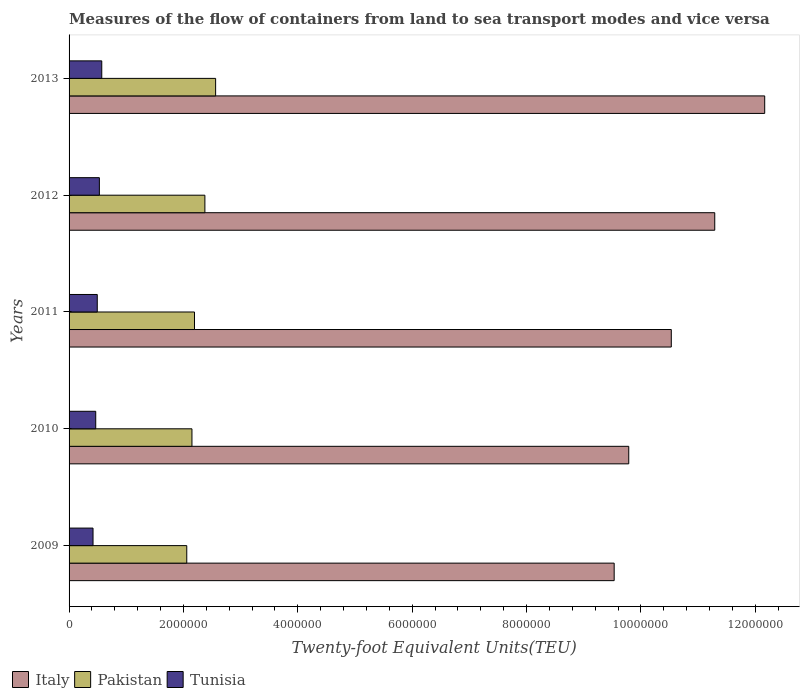How many bars are there on the 4th tick from the top?
Provide a succinct answer. 3. How many bars are there on the 4th tick from the bottom?
Keep it short and to the point. 3. In how many cases, is the number of bars for a given year not equal to the number of legend labels?
Keep it short and to the point. 0. What is the container port traffic in Pakistan in 2009?
Make the answer very short. 2.06e+06. Across all years, what is the maximum container port traffic in Pakistan?
Give a very brief answer. 2.56e+06. Across all years, what is the minimum container port traffic in Tunisia?
Provide a succinct answer. 4.19e+05. What is the total container port traffic in Pakistan in the graph?
Provide a short and direct response. 1.13e+07. What is the difference between the container port traffic in Italy in 2010 and that in 2011?
Ensure brevity in your answer.  -7.44e+05. What is the difference between the container port traffic in Italy in 2010 and the container port traffic in Pakistan in 2009?
Keep it short and to the point. 7.73e+06. What is the average container port traffic in Tunisia per year?
Provide a short and direct response. 4.96e+05. In the year 2012, what is the difference between the container port traffic in Tunisia and container port traffic in Pakistan?
Offer a terse response. -1.85e+06. In how many years, is the container port traffic in Tunisia greater than 4800000 TEU?
Offer a terse response. 0. What is the ratio of the container port traffic in Pakistan in 2012 to that in 2013?
Your response must be concise. 0.93. What is the difference between the highest and the second highest container port traffic in Tunisia?
Your answer should be compact. 4.19e+04. What is the difference between the highest and the lowest container port traffic in Pakistan?
Offer a terse response. 5.05e+05. Is the sum of the container port traffic in Tunisia in 2009 and 2012 greater than the maximum container port traffic in Italy across all years?
Ensure brevity in your answer.  No. What does the 2nd bar from the top in 2009 represents?
Offer a very short reply. Pakistan. How many bars are there?
Ensure brevity in your answer.  15. What is the difference between two consecutive major ticks on the X-axis?
Your response must be concise. 2.00e+06. How many legend labels are there?
Keep it short and to the point. 3. What is the title of the graph?
Your answer should be very brief. Measures of the flow of containers from land to sea transport modes and vice versa. What is the label or title of the X-axis?
Offer a very short reply. Twenty-foot Equivalent Units(TEU). What is the Twenty-foot Equivalent Units(TEU) in Italy in 2009?
Offer a very short reply. 9.53e+06. What is the Twenty-foot Equivalent Units(TEU) of Pakistan in 2009?
Your answer should be very brief. 2.06e+06. What is the Twenty-foot Equivalent Units(TEU) in Tunisia in 2009?
Offer a terse response. 4.19e+05. What is the Twenty-foot Equivalent Units(TEU) in Italy in 2010?
Provide a short and direct response. 9.79e+06. What is the Twenty-foot Equivalent Units(TEU) in Pakistan in 2010?
Your answer should be compact. 2.15e+06. What is the Twenty-foot Equivalent Units(TEU) of Tunisia in 2010?
Keep it short and to the point. 4.66e+05. What is the Twenty-foot Equivalent Units(TEU) of Italy in 2011?
Your answer should be compact. 1.05e+07. What is the Twenty-foot Equivalent Units(TEU) of Pakistan in 2011?
Provide a succinct answer. 2.19e+06. What is the Twenty-foot Equivalent Units(TEU) of Tunisia in 2011?
Your response must be concise. 4.93e+05. What is the Twenty-foot Equivalent Units(TEU) of Italy in 2012?
Make the answer very short. 1.13e+07. What is the Twenty-foot Equivalent Units(TEU) of Pakistan in 2012?
Give a very brief answer. 2.38e+06. What is the Twenty-foot Equivalent Units(TEU) of Tunisia in 2012?
Your answer should be compact. 5.30e+05. What is the Twenty-foot Equivalent Units(TEU) in Italy in 2013?
Provide a short and direct response. 1.22e+07. What is the Twenty-foot Equivalent Units(TEU) in Pakistan in 2013?
Offer a very short reply. 2.56e+06. What is the Twenty-foot Equivalent Units(TEU) in Tunisia in 2013?
Offer a terse response. 5.72e+05. Across all years, what is the maximum Twenty-foot Equivalent Units(TEU) of Italy?
Give a very brief answer. 1.22e+07. Across all years, what is the maximum Twenty-foot Equivalent Units(TEU) in Pakistan?
Keep it short and to the point. 2.56e+06. Across all years, what is the maximum Twenty-foot Equivalent Units(TEU) in Tunisia?
Provide a short and direct response. 5.72e+05. Across all years, what is the minimum Twenty-foot Equivalent Units(TEU) of Italy?
Provide a succinct answer. 9.53e+06. Across all years, what is the minimum Twenty-foot Equivalent Units(TEU) in Pakistan?
Offer a terse response. 2.06e+06. Across all years, what is the minimum Twenty-foot Equivalent Units(TEU) of Tunisia?
Give a very brief answer. 4.19e+05. What is the total Twenty-foot Equivalent Units(TEU) in Italy in the graph?
Ensure brevity in your answer.  5.33e+07. What is the total Twenty-foot Equivalent Units(TEU) of Pakistan in the graph?
Your answer should be very brief. 1.13e+07. What is the total Twenty-foot Equivalent Units(TEU) in Tunisia in the graph?
Your response must be concise. 2.48e+06. What is the difference between the Twenty-foot Equivalent Units(TEU) in Italy in 2009 and that in 2010?
Your answer should be compact. -2.55e+05. What is the difference between the Twenty-foot Equivalent Units(TEU) in Pakistan in 2009 and that in 2010?
Your response must be concise. -9.09e+04. What is the difference between the Twenty-foot Equivalent Units(TEU) in Tunisia in 2009 and that in 2010?
Your answer should be compact. -4.75e+04. What is the difference between the Twenty-foot Equivalent Units(TEU) of Italy in 2009 and that in 2011?
Keep it short and to the point. -9.99e+05. What is the difference between the Twenty-foot Equivalent Units(TEU) in Pakistan in 2009 and that in 2011?
Provide a succinct answer. -1.35e+05. What is the difference between the Twenty-foot Equivalent Units(TEU) in Tunisia in 2009 and that in 2011?
Your answer should be very brief. -7.41e+04. What is the difference between the Twenty-foot Equivalent Units(TEU) of Italy in 2009 and that in 2012?
Keep it short and to the point. -1.76e+06. What is the difference between the Twenty-foot Equivalent Units(TEU) of Pakistan in 2009 and that in 2012?
Your response must be concise. -3.17e+05. What is the difference between the Twenty-foot Equivalent Units(TEU) in Tunisia in 2009 and that in 2012?
Ensure brevity in your answer.  -1.11e+05. What is the difference between the Twenty-foot Equivalent Units(TEU) in Italy in 2009 and that in 2013?
Ensure brevity in your answer.  -2.63e+06. What is the difference between the Twenty-foot Equivalent Units(TEU) of Pakistan in 2009 and that in 2013?
Your answer should be very brief. -5.05e+05. What is the difference between the Twenty-foot Equivalent Units(TEU) of Tunisia in 2009 and that in 2013?
Ensure brevity in your answer.  -1.53e+05. What is the difference between the Twenty-foot Equivalent Units(TEU) of Italy in 2010 and that in 2011?
Provide a succinct answer. -7.44e+05. What is the difference between the Twenty-foot Equivalent Units(TEU) of Pakistan in 2010 and that in 2011?
Keep it short and to the point. -4.44e+04. What is the difference between the Twenty-foot Equivalent Units(TEU) in Tunisia in 2010 and that in 2011?
Your answer should be compact. -2.66e+04. What is the difference between the Twenty-foot Equivalent Units(TEU) of Italy in 2010 and that in 2012?
Make the answer very short. -1.50e+06. What is the difference between the Twenty-foot Equivalent Units(TEU) in Pakistan in 2010 and that in 2012?
Provide a short and direct response. -2.26e+05. What is the difference between the Twenty-foot Equivalent Units(TEU) of Tunisia in 2010 and that in 2012?
Ensure brevity in your answer.  -6.36e+04. What is the difference between the Twenty-foot Equivalent Units(TEU) in Italy in 2010 and that in 2013?
Your answer should be very brief. -2.38e+06. What is the difference between the Twenty-foot Equivalent Units(TEU) in Pakistan in 2010 and that in 2013?
Offer a very short reply. -4.14e+05. What is the difference between the Twenty-foot Equivalent Units(TEU) in Tunisia in 2010 and that in 2013?
Provide a short and direct response. -1.05e+05. What is the difference between the Twenty-foot Equivalent Units(TEU) of Italy in 2011 and that in 2012?
Provide a short and direct response. -7.60e+05. What is the difference between the Twenty-foot Equivalent Units(TEU) of Pakistan in 2011 and that in 2012?
Keep it short and to the point. -1.82e+05. What is the difference between the Twenty-foot Equivalent Units(TEU) of Tunisia in 2011 and that in 2012?
Provide a short and direct response. -3.70e+04. What is the difference between the Twenty-foot Equivalent Units(TEU) in Italy in 2011 and that in 2013?
Provide a short and direct response. -1.63e+06. What is the difference between the Twenty-foot Equivalent Units(TEU) in Pakistan in 2011 and that in 2013?
Give a very brief answer. -3.69e+05. What is the difference between the Twenty-foot Equivalent Units(TEU) in Tunisia in 2011 and that in 2013?
Offer a terse response. -7.88e+04. What is the difference between the Twenty-foot Equivalent Units(TEU) of Italy in 2012 and that in 2013?
Your answer should be compact. -8.74e+05. What is the difference between the Twenty-foot Equivalent Units(TEU) in Pakistan in 2012 and that in 2013?
Your answer should be very brief. -1.88e+05. What is the difference between the Twenty-foot Equivalent Units(TEU) in Tunisia in 2012 and that in 2013?
Make the answer very short. -4.19e+04. What is the difference between the Twenty-foot Equivalent Units(TEU) in Italy in 2009 and the Twenty-foot Equivalent Units(TEU) in Pakistan in 2010?
Keep it short and to the point. 7.38e+06. What is the difference between the Twenty-foot Equivalent Units(TEU) in Italy in 2009 and the Twenty-foot Equivalent Units(TEU) in Tunisia in 2010?
Offer a terse response. 9.07e+06. What is the difference between the Twenty-foot Equivalent Units(TEU) in Pakistan in 2009 and the Twenty-foot Equivalent Units(TEU) in Tunisia in 2010?
Your answer should be very brief. 1.59e+06. What is the difference between the Twenty-foot Equivalent Units(TEU) in Italy in 2009 and the Twenty-foot Equivalent Units(TEU) in Pakistan in 2011?
Give a very brief answer. 7.34e+06. What is the difference between the Twenty-foot Equivalent Units(TEU) of Italy in 2009 and the Twenty-foot Equivalent Units(TEU) of Tunisia in 2011?
Provide a short and direct response. 9.04e+06. What is the difference between the Twenty-foot Equivalent Units(TEU) of Pakistan in 2009 and the Twenty-foot Equivalent Units(TEU) of Tunisia in 2011?
Your answer should be very brief. 1.57e+06. What is the difference between the Twenty-foot Equivalent Units(TEU) in Italy in 2009 and the Twenty-foot Equivalent Units(TEU) in Pakistan in 2012?
Your response must be concise. 7.16e+06. What is the difference between the Twenty-foot Equivalent Units(TEU) of Italy in 2009 and the Twenty-foot Equivalent Units(TEU) of Tunisia in 2012?
Keep it short and to the point. 9.00e+06. What is the difference between the Twenty-foot Equivalent Units(TEU) of Pakistan in 2009 and the Twenty-foot Equivalent Units(TEU) of Tunisia in 2012?
Ensure brevity in your answer.  1.53e+06. What is the difference between the Twenty-foot Equivalent Units(TEU) in Italy in 2009 and the Twenty-foot Equivalent Units(TEU) in Pakistan in 2013?
Your response must be concise. 6.97e+06. What is the difference between the Twenty-foot Equivalent Units(TEU) of Italy in 2009 and the Twenty-foot Equivalent Units(TEU) of Tunisia in 2013?
Give a very brief answer. 8.96e+06. What is the difference between the Twenty-foot Equivalent Units(TEU) of Pakistan in 2009 and the Twenty-foot Equivalent Units(TEU) of Tunisia in 2013?
Offer a very short reply. 1.49e+06. What is the difference between the Twenty-foot Equivalent Units(TEU) in Italy in 2010 and the Twenty-foot Equivalent Units(TEU) in Pakistan in 2011?
Keep it short and to the point. 7.59e+06. What is the difference between the Twenty-foot Equivalent Units(TEU) in Italy in 2010 and the Twenty-foot Equivalent Units(TEU) in Tunisia in 2011?
Give a very brief answer. 9.29e+06. What is the difference between the Twenty-foot Equivalent Units(TEU) of Pakistan in 2010 and the Twenty-foot Equivalent Units(TEU) of Tunisia in 2011?
Offer a very short reply. 1.66e+06. What is the difference between the Twenty-foot Equivalent Units(TEU) in Italy in 2010 and the Twenty-foot Equivalent Units(TEU) in Pakistan in 2012?
Offer a terse response. 7.41e+06. What is the difference between the Twenty-foot Equivalent Units(TEU) of Italy in 2010 and the Twenty-foot Equivalent Units(TEU) of Tunisia in 2012?
Give a very brief answer. 9.26e+06. What is the difference between the Twenty-foot Equivalent Units(TEU) in Pakistan in 2010 and the Twenty-foot Equivalent Units(TEU) in Tunisia in 2012?
Make the answer very short. 1.62e+06. What is the difference between the Twenty-foot Equivalent Units(TEU) in Italy in 2010 and the Twenty-foot Equivalent Units(TEU) in Pakistan in 2013?
Provide a short and direct response. 7.22e+06. What is the difference between the Twenty-foot Equivalent Units(TEU) of Italy in 2010 and the Twenty-foot Equivalent Units(TEU) of Tunisia in 2013?
Your answer should be compact. 9.22e+06. What is the difference between the Twenty-foot Equivalent Units(TEU) of Pakistan in 2010 and the Twenty-foot Equivalent Units(TEU) of Tunisia in 2013?
Your answer should be compact. 1.58e+06. What is the difference between the Twenty-foot Equivalent Units(TEU) of Italy in 2011 and the Twenty-foot Equivalent Units(TEU) of Pakistan in 2012?
Provide a short and direct response. 8.16e+06. What is the difference between the Twenty-foot Equivalent Units(TEU) of Italy in 2011 and the Twenty-foot Equivalent Units(TEU) of Tunisia in 2012?
Your answer should be compact. 1.00e+07. What is the difference between the Twenty-foot Equivalent Units(TEU) in Pakistan in 2011 and the Twenty-foot Equivalent Units(TEU) in Tunisia in 2012?
Provide a short and direct response. 1.66e+06. What is the difference between the Twenty-foot Equivalent Units(TEU) of Italy in 2011 and the Twenty-foot Equivalent Units(TEU) of Pakistan in 2013?
Offer a very short reply. 7.97e+06. What is the difference between the Twenty-foot Equivalent Units(TEU) in Italy in 2011 and the Twenty-foot Equivalent Units(TEU) in Tunisia in 2013?
Give a very brief answer. 9.96e+06. What is the difference between the Twenty-foot Equivalent Units(TEU) of Pakistan in 2011 and the Twenty-foot Equivalent Units(TEU) of Tunisia in 2013?
Your answer should be very brief. 1.62e+06. What is the difference between the Twenty-foot Equivalent Units(TEU) of Italy in 2012 and the Twenty-foot Equivalent Units(TEU) of Pakistan in 2013?
Offer a terse response. 8.73e+06. What is the difference between the Twenty-foot Equivalent Units(TEU) of Italy in 2012 and the Twenty-foot Equivalent Units(TEU) of Tunisia in 2013?
Ensure brevity in your answer.  1.07e+07. What is the difference between the Twenty-foot Equivalent Units(TEU) of Pakistan in 2012 and the Twenty-foot Equivalent Units(TEU) of Tunisia in 2013?
Provide a succinct answer. 1.80e+06. What is the average Twenty-foot Equivalent Units(TEU) of Italy per year?
Provide a short and direct response. 1.07e+07. What is the average Twenty-foot Equivalent Units(TEU) of Pakistan per year?
Keep it short and to the point. 2.27e+06. What is the average Twenty-foot Equivalent Units(TEU) in Tunisia per year?
Keep it short and to the point. 4.96e+05. In the year 2009, what is the difference between the Twenty-foot Equivalent Units(TEU) in Italy and Twenty-foot Equivalent Units(TEU) in Pakistan?
Your answer should be very brief. 7.47e+06. In the year 2009, what is the difference between the Twenty-foot Equivalent Units(TEU) of Italy and Twenty-foot Equivalent Units(TEU) of Tunisia?
Offer a terse response. 9.11e+06. In the year 2009, what is the difference between the Twenty-foot Equivalent Units(TEU) in Pakistan and Twenty-foot Equivalent Units(TEU) in Tunisia?
Provide a short and direct response. 1.64e+06. In the year 2010, what is the difference between the Twenty-foot Equivalent Units(TEU) in Italy and Twenty-foot Equivalent Units(TEU) in Pakistan?
Provide a short and direct response. 7.64e+06. In the year 2010, what is the difference between the Twenty-foot Equivalent Units(TEU) in Italy and Twenty-foot Equivalent Units(TEU) in Tunisia?
Your answer should be very brief. 9.32e+06. In the year 2010, what is the difference between the Twenty-foot Equivalent Units(TEU) of Pakistan and Twenty-foot Equivalent Units(TEU) of Tunisia?
Keep it short and to the point. 1.68e+06. In the year 2011, what is the difference between the Twenty-foot Equivalent Units(TEU) of Italy and Twenty-foot Equivalent Units(TEU) of Pakistan?
Give a very brief answer. 8.34e+06. In the year 2011, what is the difference between the Twenty-foot Equivalent Units(TEU) of Italy and Twenty-foot Equivalent Units(TEU) of Tunisia?
Your answer should be very brief. 1.00e+07. In the year 2011, what is the difference between the Twenty-foot Equivalent Units(TEU) of Pakistan and Twenty-foot Equivalent Units(TEU) of Tunisia?
Ensure brevity in your answer.  1.70e+06. In the year 2012, what is the difference between the Twenty-foot Equivalent Units(TEU) in Italy and Twenty-foot Equivalent Units(TEU) in Pakistan?
Ensure brevity in your answer.  8.92e+06. In the year 2012, what is the difference between the Twenty-foot Equivalent Units(TEU) of Italy and Twenty-foot Equivalent Units(TEU) of Tunisia?
Your response must be concise. 1.08e+07. In the year 2012, what is the difference between the Twenty-foot Equivalent Units(TEU) of Pakistan and Twenty-foot Equivalent Units(TEU) of Tunisia?
Your answer should be compact. 1.85e+06. In the year 2013, what is the difference between the Twenty-foot Equivalent Units(TEU) in Italy and Twenty-foot Equivalent Units(TEU) in Pakistan?
Your response must be concise. 9.60e+06. In the year 2013, what is the difference between the Twenty-foot Equivalent Units(TEU) in Italy and Twenty-foot Equivalent Units(TEU) in Tunisia?
Provide a short and direct response. 1.16e+07. In the year 2013, what is the difference between the Twenty-foot Equivalent Units(TEU) of Pakistan and Twenty-foot Equivalent Units(TEU) of Tunisia?
Keep it short and to the point. 1.99e+06. What is the ratio of the Twenty-foot Equivalent Units(TEU) in Italy in 2009 to that in 2010?
Your response must be concise. 0.97. What is the ratio of the Twenty-foot Equivalent Units(TEU) in Pakistan in 2009 to that in 2010?
Make the answer very short. 0.96. What is the ratio of the Twenty-foot Equivalent Units(TEU) of Tunisia in 2009 to that in 2010?
Your answer should be compact. 0.9. What is the ratio of the Twenty-foot Equivalent Units(TEU) of Italy in 2009 to that in 2011?
Offer a very short reply. 0.91. What is the ratio of the Twenty-foot Equivalent Units(TEU) of Pakistan in 2009 to that in 2011?
Offer a very short reply. 0.94. What is the ratio of the Twenty-foot Equivalent Units(TEU) of Tunisia in 2009 to that in 2011?
Your answer should be compact. 0.85. What is the ratio of the Twenty-foot Equivalent Units(TEU) in Italy in 2009 to that in 2012?
Your answer should be compact. 0.84. What is the ratio of the Twenty-foot Equivalent Units(TEU) in Pakistan in 2009 to that in 2012?
Provide a succinct answer. 0.87. What is the ratio of the Twenty-foot Equivalent Units(TEU) of Tunisia in 2009 to that in 2012?
Offer a terse response. 0.79. What is the ratio of the Twenty-foot Equivalent Units(TEU) in Italy in 2009 to that in 2013?
Provide a short and direct response. 0.78. What is the ratio of the Twenty-foot Equivalent Units(TEU) in Pakistan in 2009 to that in 2013?
Provide a short and direct response. 0.8. What is the ratio of the Twenty-foot Equivalent Units(TEU) in Tunisia in 2009 to that in 2013?
Keep it short and to the point. 0.73. What is the ratio of the Twenty-foot Equivalent Units(TEU) of Italy in 2010 to that in 2011?
Your answer should be compact. 0.93. What is the ratio of the Twenty-foot Equivalent Units(TEU) of Pakistan in 2010 to that in 2011?
Give a very brief answer. 0.98. What is the ratio of the Twenty-foot Equivalent Units(TEU) in Tunisia in 2010 to that in 2011?
Keep it short and to the point. 0.95. What is the ratio of the Twenty-foot Equivalent Units(TEU) of Italy in 2010 to that in 2012?
Your answer should be very brief. 0.87. What is the ratio of the Twenty-foot Equivalent Units(TEU) in Pakistan in 2010 to that in 2012?
Provide a succinct answer. 0.9. What is the ratio of the Twenty-foot Equivalent Units(TEU) in Tunisia in 2010 to that in 2012?
Provide a short and direct response. 0.88. What is the ratio of the Twenty-foot Equivalent Units(TEU) in Italy in 2010 to that in 2013?
Make the answer very short. 0.8. What is the ratio of the Twenty-foot Equivalent Units(TEU) in Pakistan in 2010 to that in 2013?
Provide a succinct answer. 0.84. What is the ratio of the Twenty-foot Equivalent Units(TEU) in Tunisia in 2010 to that in 2013?
Your response must be concise. 0.82. What is the ratio of the Twenty-foot Equivalent Units(TEU) of Italy in 2011 to that in 2012?
Offer a terse response. 0.93. What is the ratio of the Twenty-foot Equivalent Units(TEU) in Pakistan in 2011 to that in 2012?
Provide a succinct answer. 0.92. What is the ratio of the Twenty-foot Equivalent Units(TEU) in Tunisia in 2011 to that in 2012?
Provide a short and direct response. 0.93. What is the ratio of the Twenty-foot Equivalent Units(TEU) of Italy in 2011 to that in 2013?
Your answer should be compact. 0.87. What is the ratio of the Twenty-foot Equivalent Units(TEU) in Pakistan in 2011 to that in 2013?
Offer a terse response. 0.86. What is the ratio of the Twenty-foot Equivalent Units(TEU) of Tunisia in 2011 to that in 2013?
Your answer should be very brief. 0.86. What is the ratio of the Twenty-foot Equivalent Units(TEU) of Italy in 2012 to that in 2013?
Give a very brief answer. 0.93. What is the ratio of the Twenty-foot Equivalent Units(TEU) in Pakistan in 2012 to that in 2013?
Your response must be concise. 0.93. What is the ratio of the Twenty-foot Equivalent Units(TEU) of Tunisia in 2012 to that in 2013?
Provide a succinct answer. 0.93. What is the difference between the highest and the second highest Twenty-foot Equivalent Units(TEU) of Italy?
Give a very brief answer. 8.74e+05. What is the difference between the highest and the second highest Twenty-foot Equivalent Units(TEU) of Pakistan?
Make the answer very short. 1.88e+05. What is the difference between the highest and the second highest Twenty-foot Equivalent Units(TEU) of Tunisia?
Give a very brief answer. 4.19e+04. What is the difference between the highest and the lowest Twenty-foot Equivalent Units(TEU) in Italy?
Your answer should be very brief. 2.63e+06. What is the difference between the highest and the lowest Twenty-foot Equivalent Units(TEU) in Pakistan?
Make the answer very short. 5.05e+05. What is the difference between the highest and the lowest Twenty-foot Equivalent Units(TEU) of Tunisia?
Give a very brief answer. 1.53e+05. 